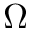<formula> <loc_0><loc_0><loc_500><loc_500>\Omega</formula> 